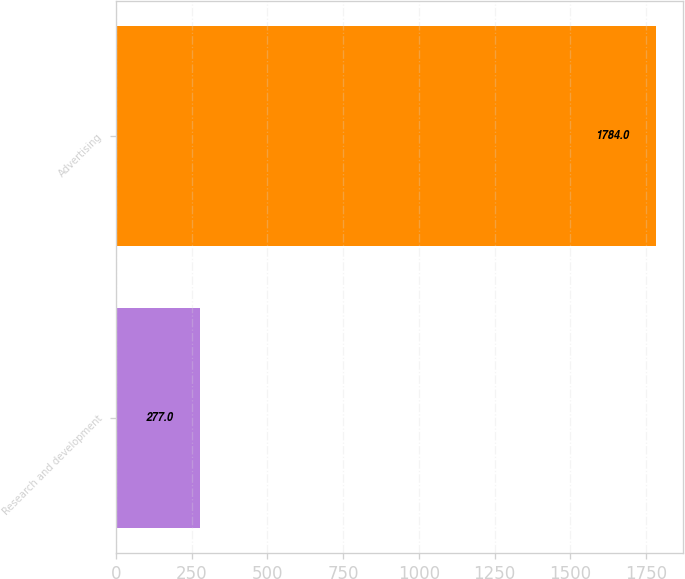Convert chart to OTSL. <chart><loc_0><loc_0><loc_500><loc_500><bar_chart><fcel>Research and development<fcel>Advertising<nl><fcel>277<fcel>1784<nl></chart> 